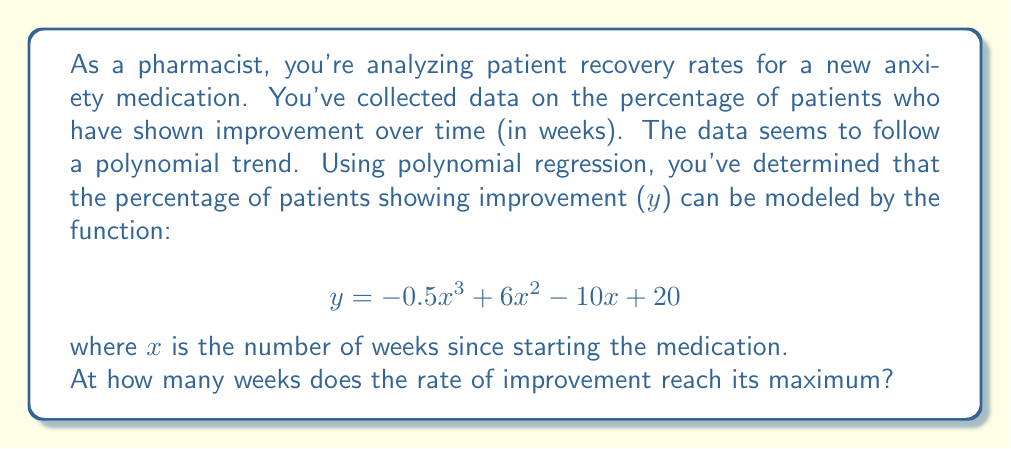Can you solve this math problem? To find when the rate of improvement reaches its maximum, we need to follow these steps:

1) The rate of improvement is represented by the first derivative of the function. Let's call this $y'$.

$$ y' = \frac{dy}{dx} = -1.5x^2 + 12x - 10 $$

2) The maximum rate occurs when the second derivative equals zero. So, we need to find the second derivative and set it to zero.

$$ y'' = \frac{d^2y}{dx^2} = -3x + 12 $$

3) Set $y'' = 0$ and solve for x:

$$ -3x + 12 = 0 $$
$$ -3x = -12 $$
$$ x = 4 $$

4) To confirm this is a maximum (not a minimum), we can check that $y'''$ is negative:

$$ y''' = -3 $$

Since this is negative, we confirm that x = 4 gives a maximum.

5) Therefore, the rate of improvement reaches its maximum at 4 weeks.

This aligns with the pharmacist's mindfulness practice, as it's important to be aware that improvement rates can change over time, reaching a peak before potentially slowing down.
Answer: 4 weeks 